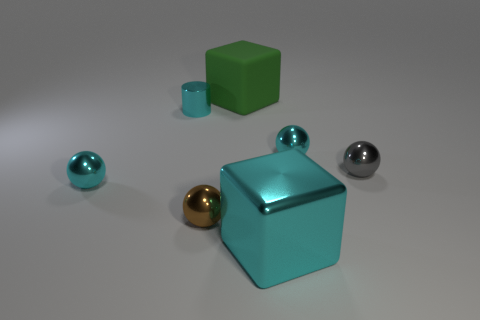Are there any gray rubber things of the same shape as the green matte thing? While there are several objects in the image, none of them are gray rubber things with the same shape as the green matte object, which is a cube. There is a metallic gray sphere and a metallic gold sphere, as well as teal glossy objects that include a cube and a sphere. 